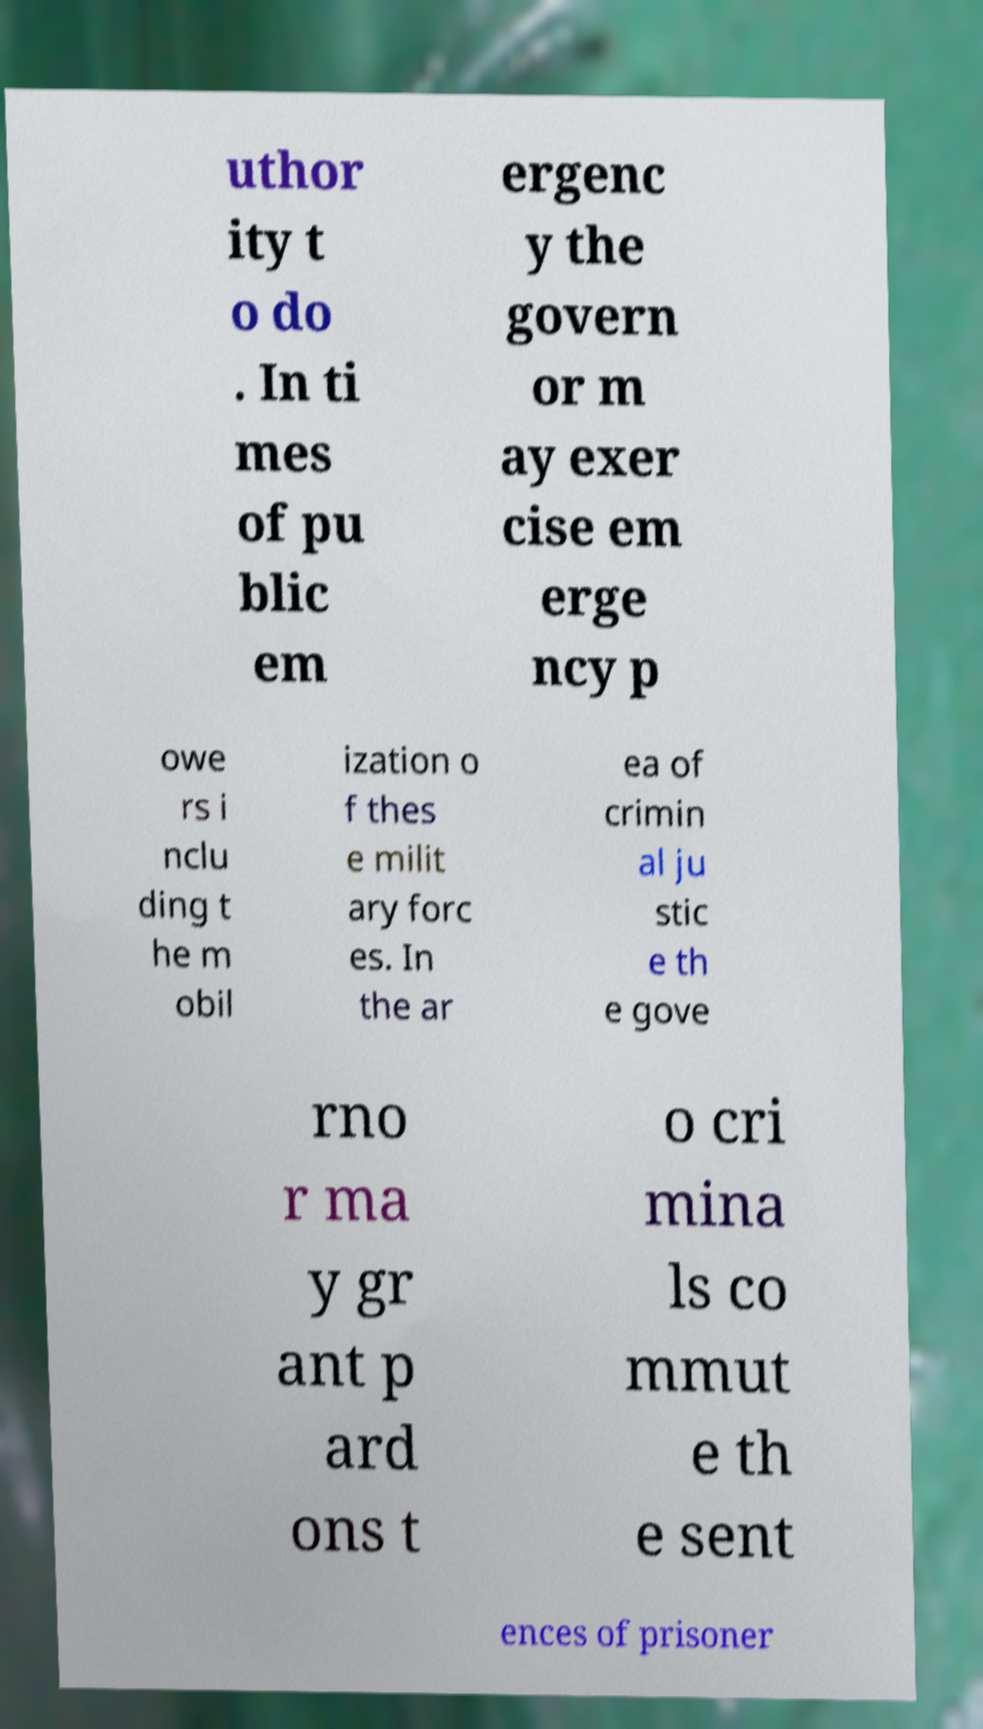There's text embedded in this image that I need extracted. Can you transcribe it verbatim? uthor ity t o do . In ti mes of pu blic em ergenc y the govern or m ay exer cise em erge ncy p owe rs i nclu ding t he m obil ization o f thes e milit ary forc es. In the ar ea of crimin al ju stic e th e gove rno r ma y gr ant p ard ons t o cri mina ls co mmut e th e sent ences of prisoner 